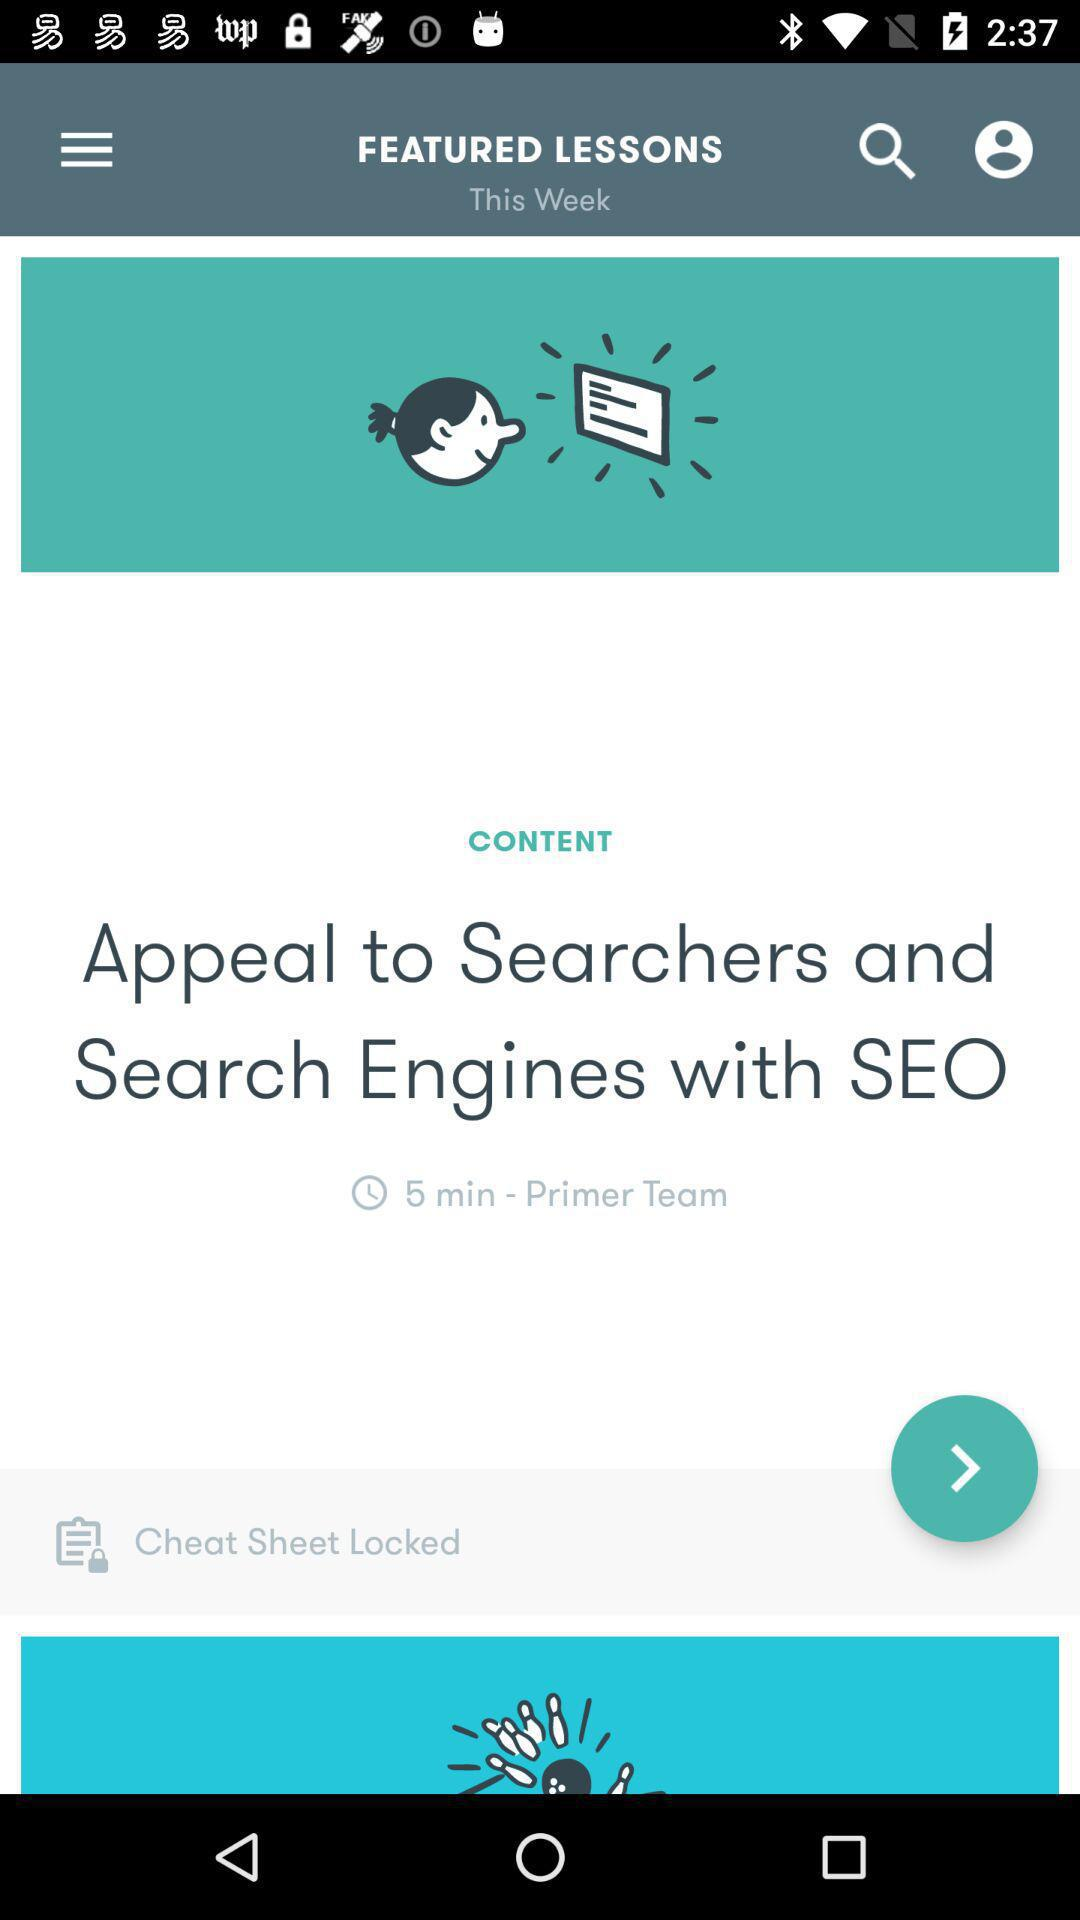What is the title of the content? The title of the content is "Appeal to Searchers and Search Engines with SEO". 